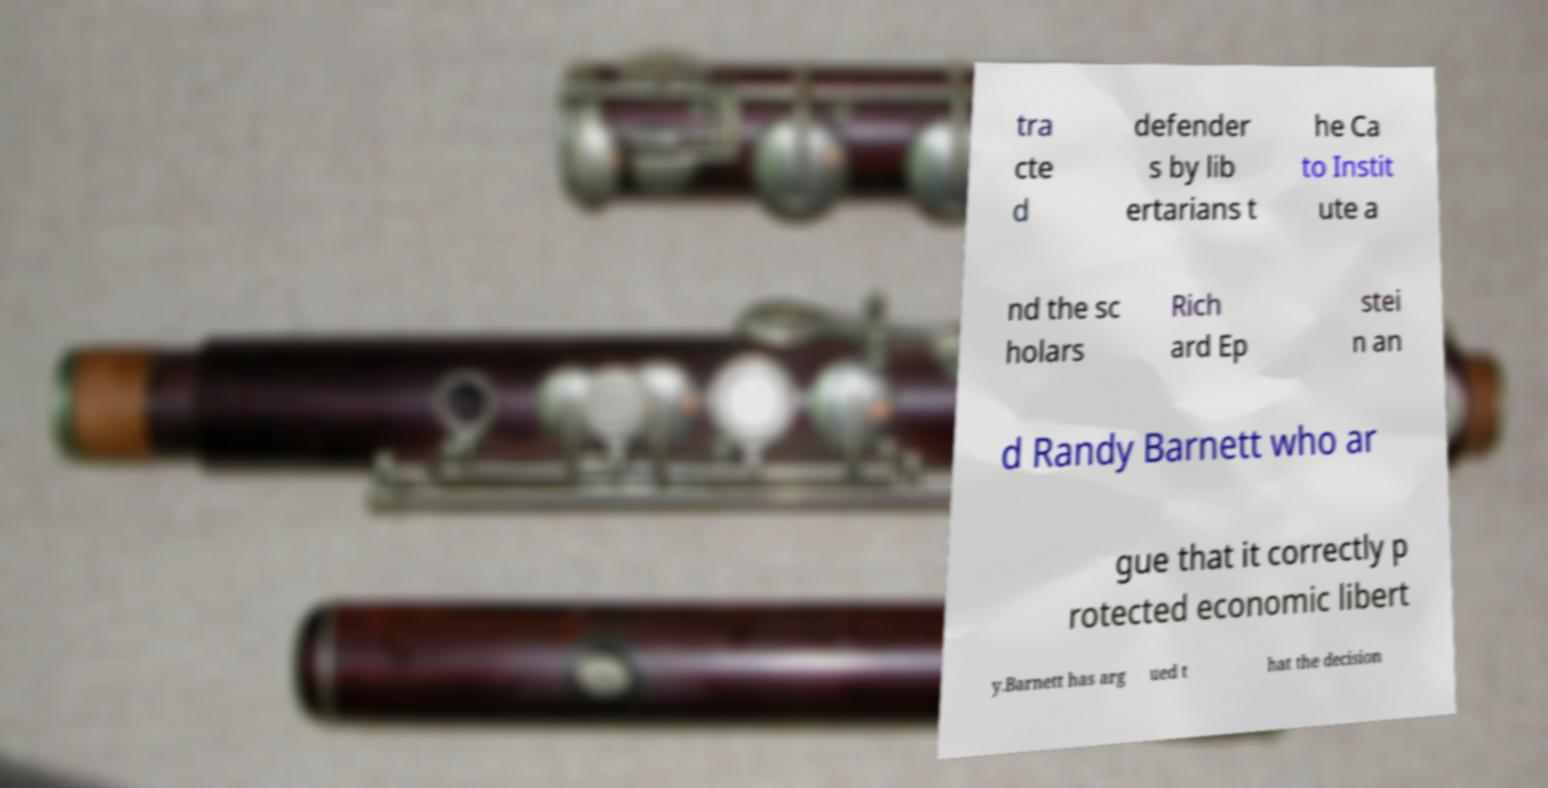What messages or text are displayed in this image? I need them in a readable, typed format. tra cte d defender s by lib ertarians t he Ca to Instit ute a nd the sc holars Rich ard Ep stei n an d Randy Barnett who ar gue that it correctly p rotected economic libert y.Barnett has arg ued t hat the decision 